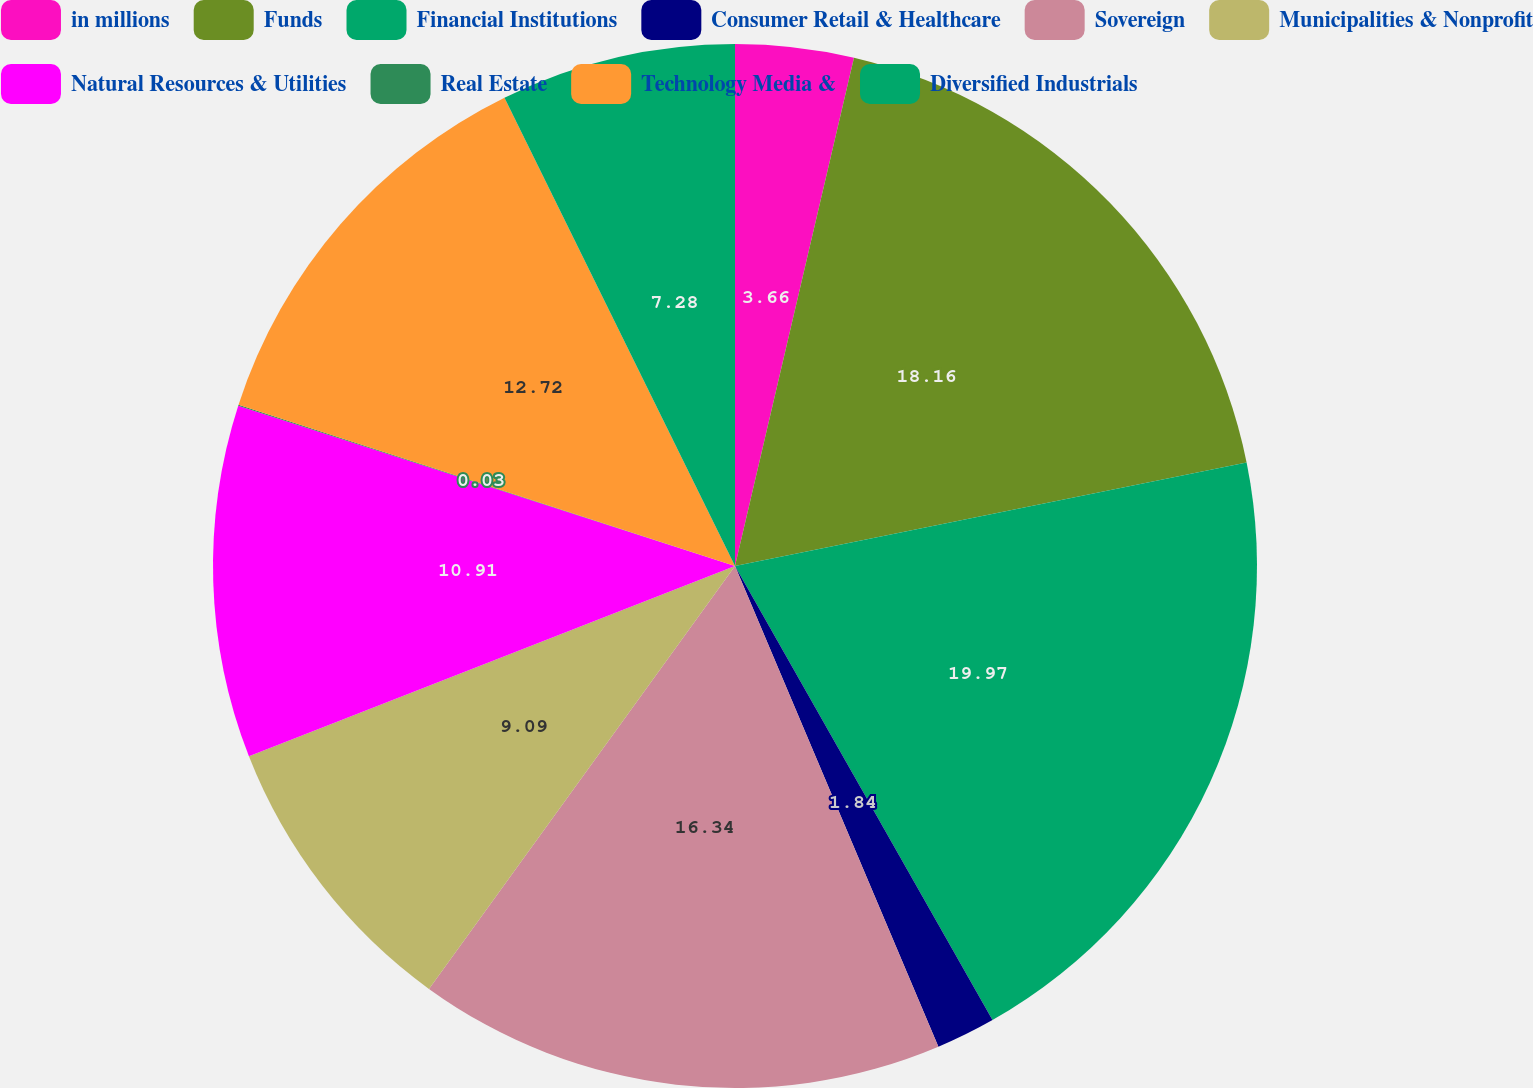Convert chart to OTSL. <chart><loc_0><loc_0><loc_500><loc_500><pie_chart><fcel>in millions<fcel>Funds<fcel>Financial Institutions<fcel>Consumer Retail & Healthcare<fcel>Sovereign<fcel>Municipalities & Nonprofit<fcel>Natural Resources & Utilities<fcel>Real Estate<fcel>Technology Media &<fcel>Diversified Industrials<nl><fcel>3.66%<fcel>18.16%<fcel>19.97%<fcel>1.84%<fcel>16.34%<fcel>9.09%<fcel>10.91%<fcel>0.03%<fcel>12.72%<fcel>7.28%<nl></chart> 